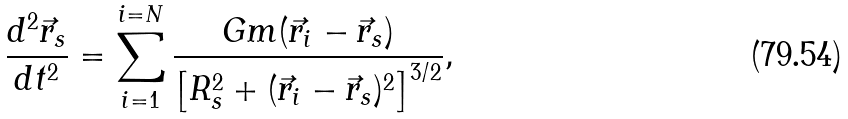<formula> <loc_0><loc_0><loc_500><loc_500>\frac { d ^ { 2 } \vec { r } _ { s } } { d t ^ { 2 } } = \sum _ { i = 1 } ^ { i = N } \frac { G m ( \vec { r } _ { i } - \vec { r } _ { s } ) } { \left [ R _ { s } ^ { 2 } + ( \vec { r } _ { i } - \vec { r } _ { s } ) ^ { 2 } \right ] ^ { 3 / 2 } } ,</formula> 